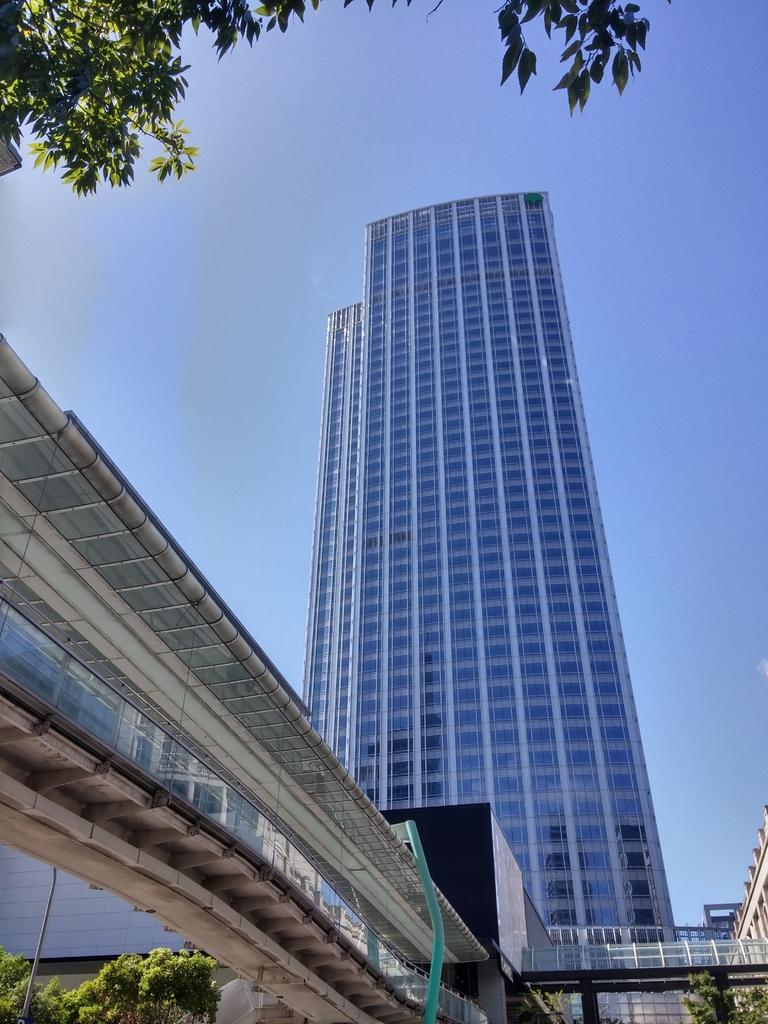What structures are located in the center of the image? There are buildings, a bridge, and a wall in the center of the image. What architectural feature can be seen in the center of the image? There are windows in the center of the image. What type of vegetation is visible at the bottom of the image? Trees are visible at the bottom of the image. What is visible in the background of the image? The sky is visible in the background of the image. Can you see a bear giving someone a kiss in the image? There is no bear or kissing activity present in the image. What is an example of a structure that is not present in the image? An example of a structure that is not present in the image is a lighthouse. 